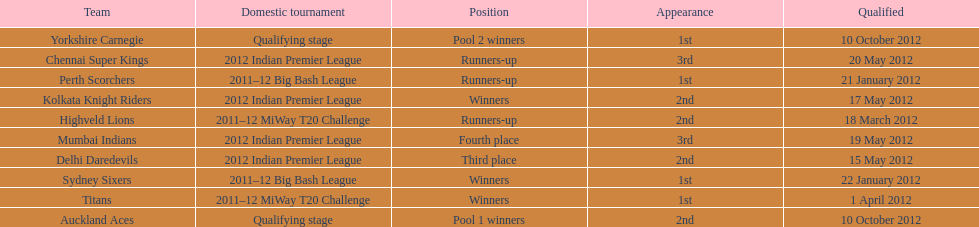Which team made their first appearance in the same tournament as the perth scorchers? Sydney Sixers. 